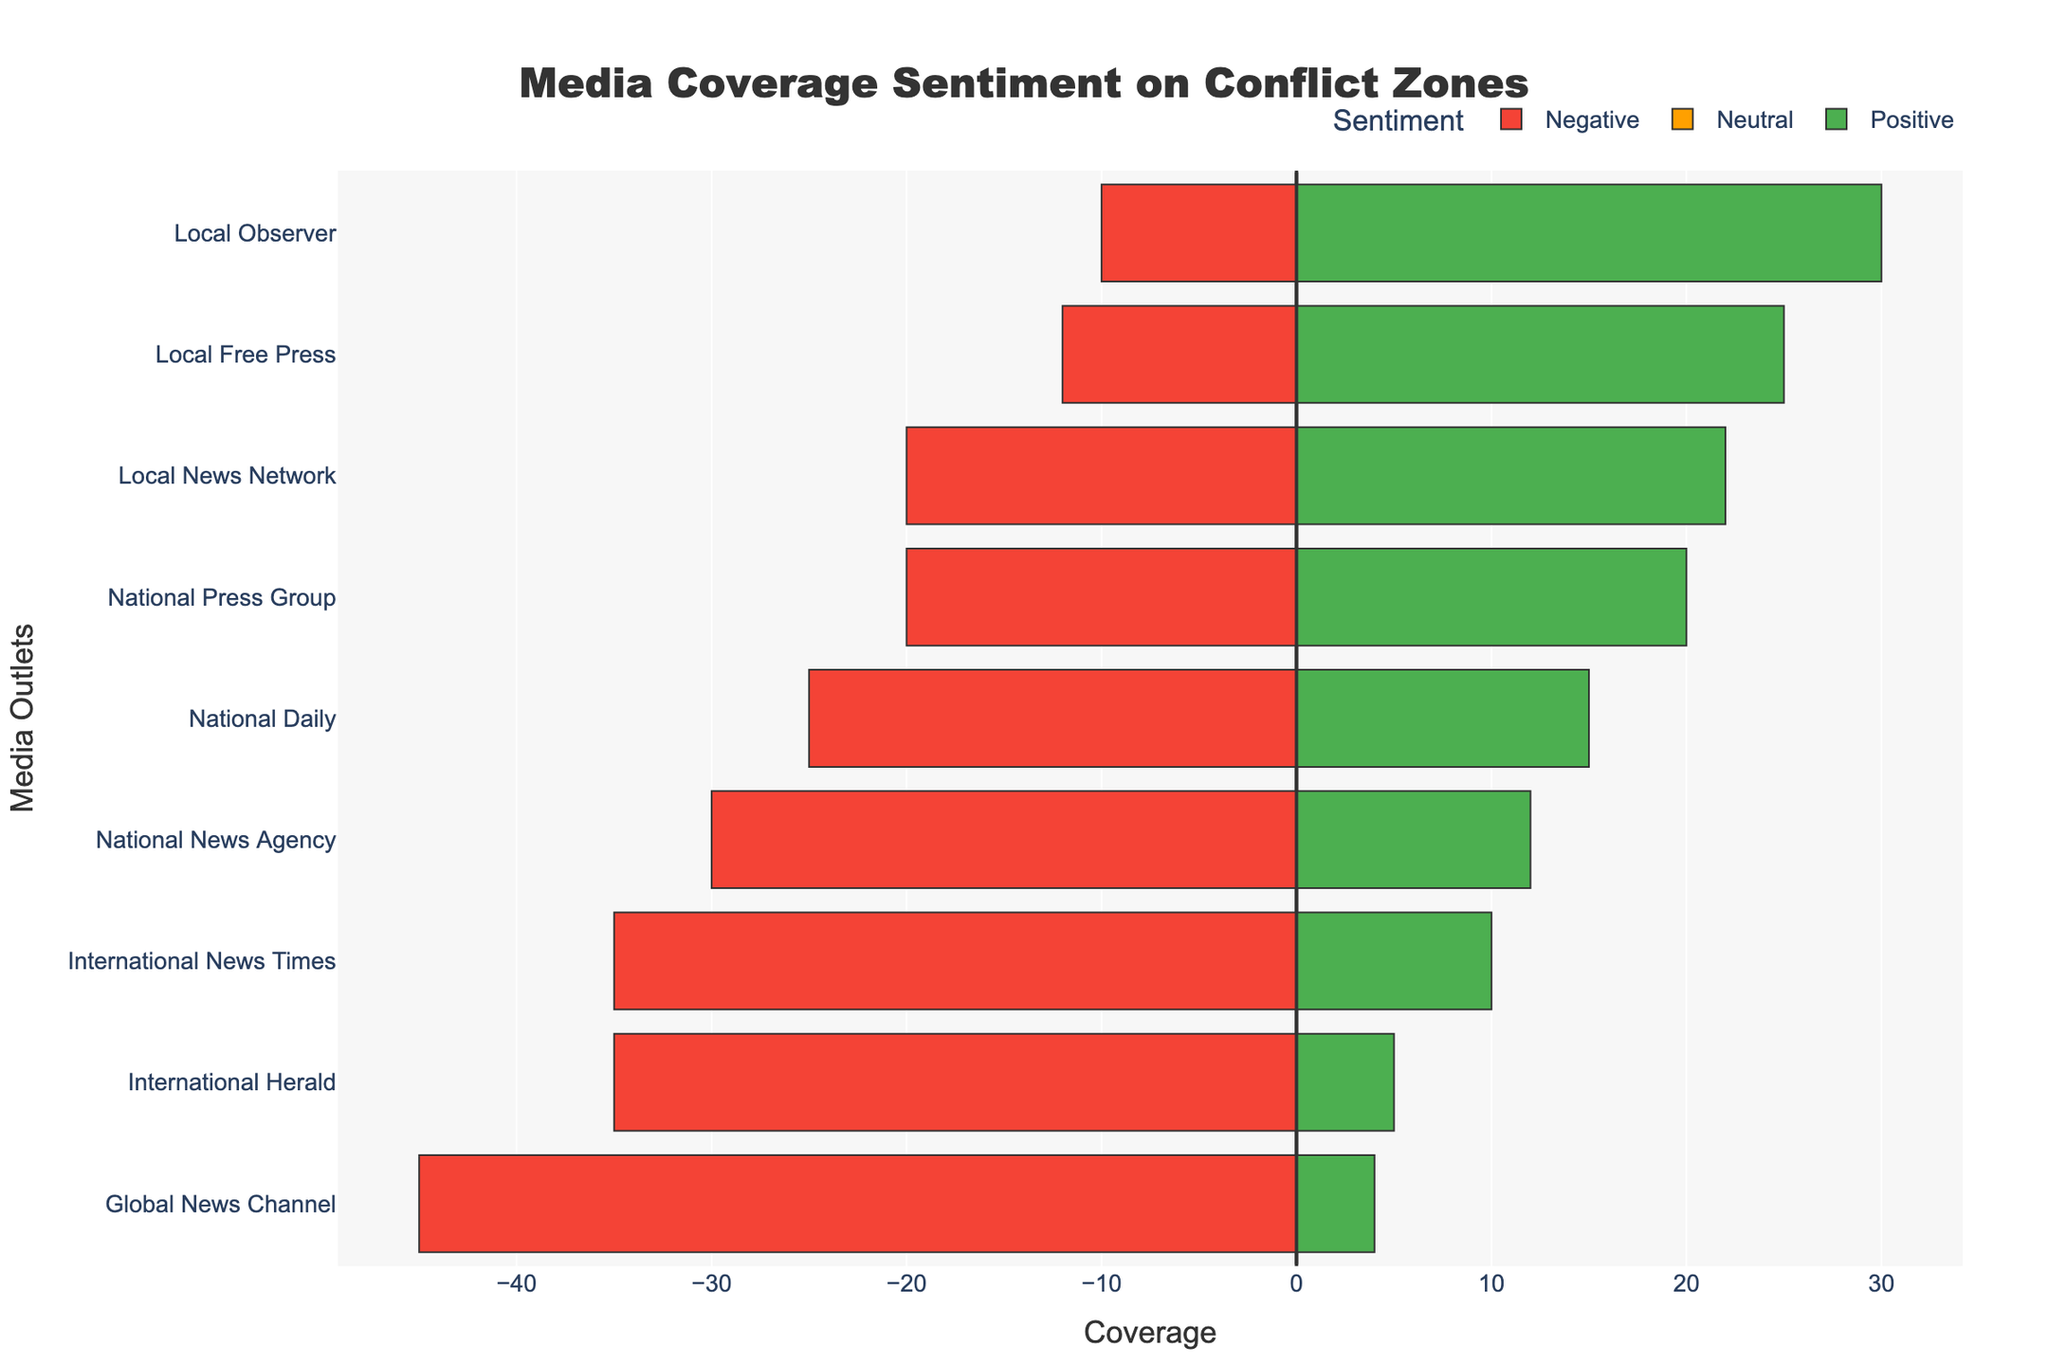Which outlet has the highest negative coverage? Look at the bars representing negative coverage (in red). The longest bar represents the highest negative coverage. Global News Channel has the longest negative coverage bar.
Answer: Global News Channel What is the total positive coverage for local outlets in Aleppo? Sum up the positive coverage values for all local outlets in Aleppo. The Local News Network has 10, and the Global News Channel, though primarily an international outlet, also covers Aleppo with 30, but for local, we only consider the Local News Network.
Answer: 10 Compare the national outlets’ neutral coverage across different locations and state which has the highest. Compare the neutral bars of National News Agency (Damascus), National Daily (Homs), and National Press Group (Latakia). National Daily has the tallest neutral bar.
Answer: National Daily What is the difference in negative coverage between International News Times and National Daily in Idlib and Homs respectively? International News Times has a negative coverage of 35 in Idlib. National Daily has a negative coverage of 25 in Homs. The difference is 35 - 25.
Answer: 10 What percentage of the coverage by Local Free Press in Raqqa is neutral? Local Free Press in Raqqa has a total coverage (sum of positive, neutral, and negative) of 5 + 3 + 12 = 20. The neutral coverage is 3. The percentage is (3/20) * 100.
Answer: 15% Which outlet has the most balanced coverage sentiment (positive, neutral, and negative are closest in value) in any given location? Examine the outlets where the lengths of positive, neutral, and negative bars are closest in length. Local News Network in Aleppo and International Herald in Homs appear to have a more balanced sentiment. Local News Network: (10, 5, 20) and International Herald: (22, 18, 35); however, International Herald has closer numbers.
Answer: International Herald What is the difference in total coverage between National Press Group in Latakia and Local Observer in Daraa? Sum the coverage values for National Press Group in Latakia (positive: 12, neutral: 8, negative: 20) and Local Observer in Daraa (positive: 4, neutral: 2, negative: 10). National Press Group: 12+8+20=40. Local Observer: 4+2+10=16. The difference is 40 - 16.
Answer: 24 Which outlet has the highest positive coverage in any location? Observe the green bars which indicate positive coverage. The longest green bar is for Global News Channel in Aleppo (30).
Answer: Global News Channel What is the average neutral coverage of all international outlets? International outlets are International News Times (neutral: 20), Global News Channel (neutral: 25), and International Herald (neutral: 18). The average is (20+25+18)/3.
Answer: 21 